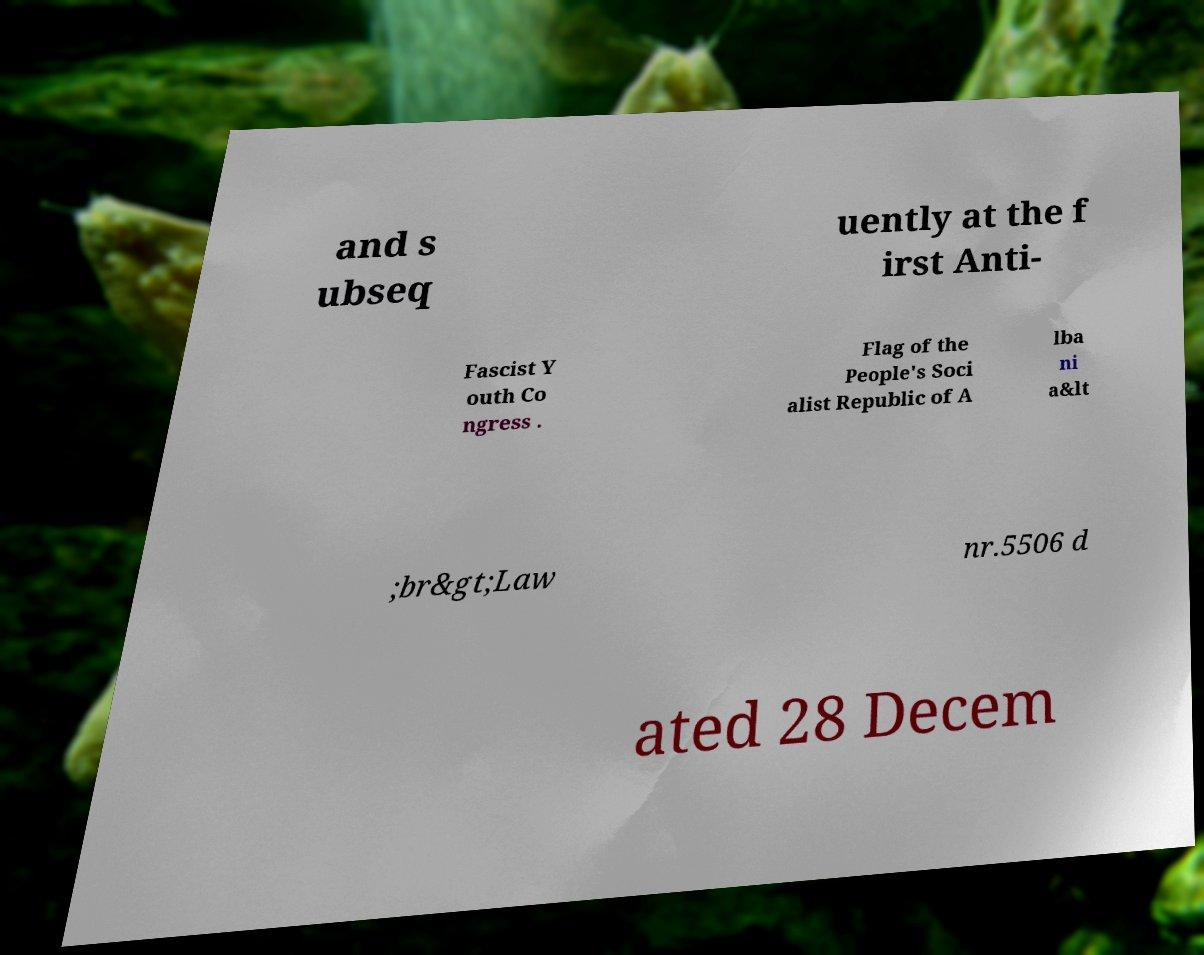I need the written content from this picture converted into text. Can you do that? and s ubseq uently at the f irst Anti- Fascist Y outh Co ngress . Flag of the People's Soci alist Republic of A lba ni a&lt ;br&gt;Law nr.5506 d ated 28 Decem 